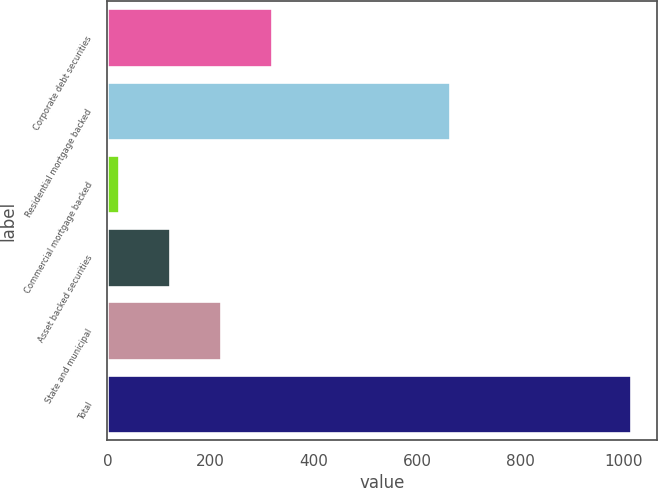Convert chart to OTSL. <chart><loc_0><loc_0><loc_500><loc_500><bar_chart><fcel>Corporate debt securities<fcel>Residential mortgage backed<fcel>Commercial mortgage backed<fcel>Asset backed securities<fcel>State and municipal<fcel>Total<nl><fcel>319.9<fcel>663<fcel>22<fcel>121.3<fcel>220.6<fcel>1015<nl></chart> 